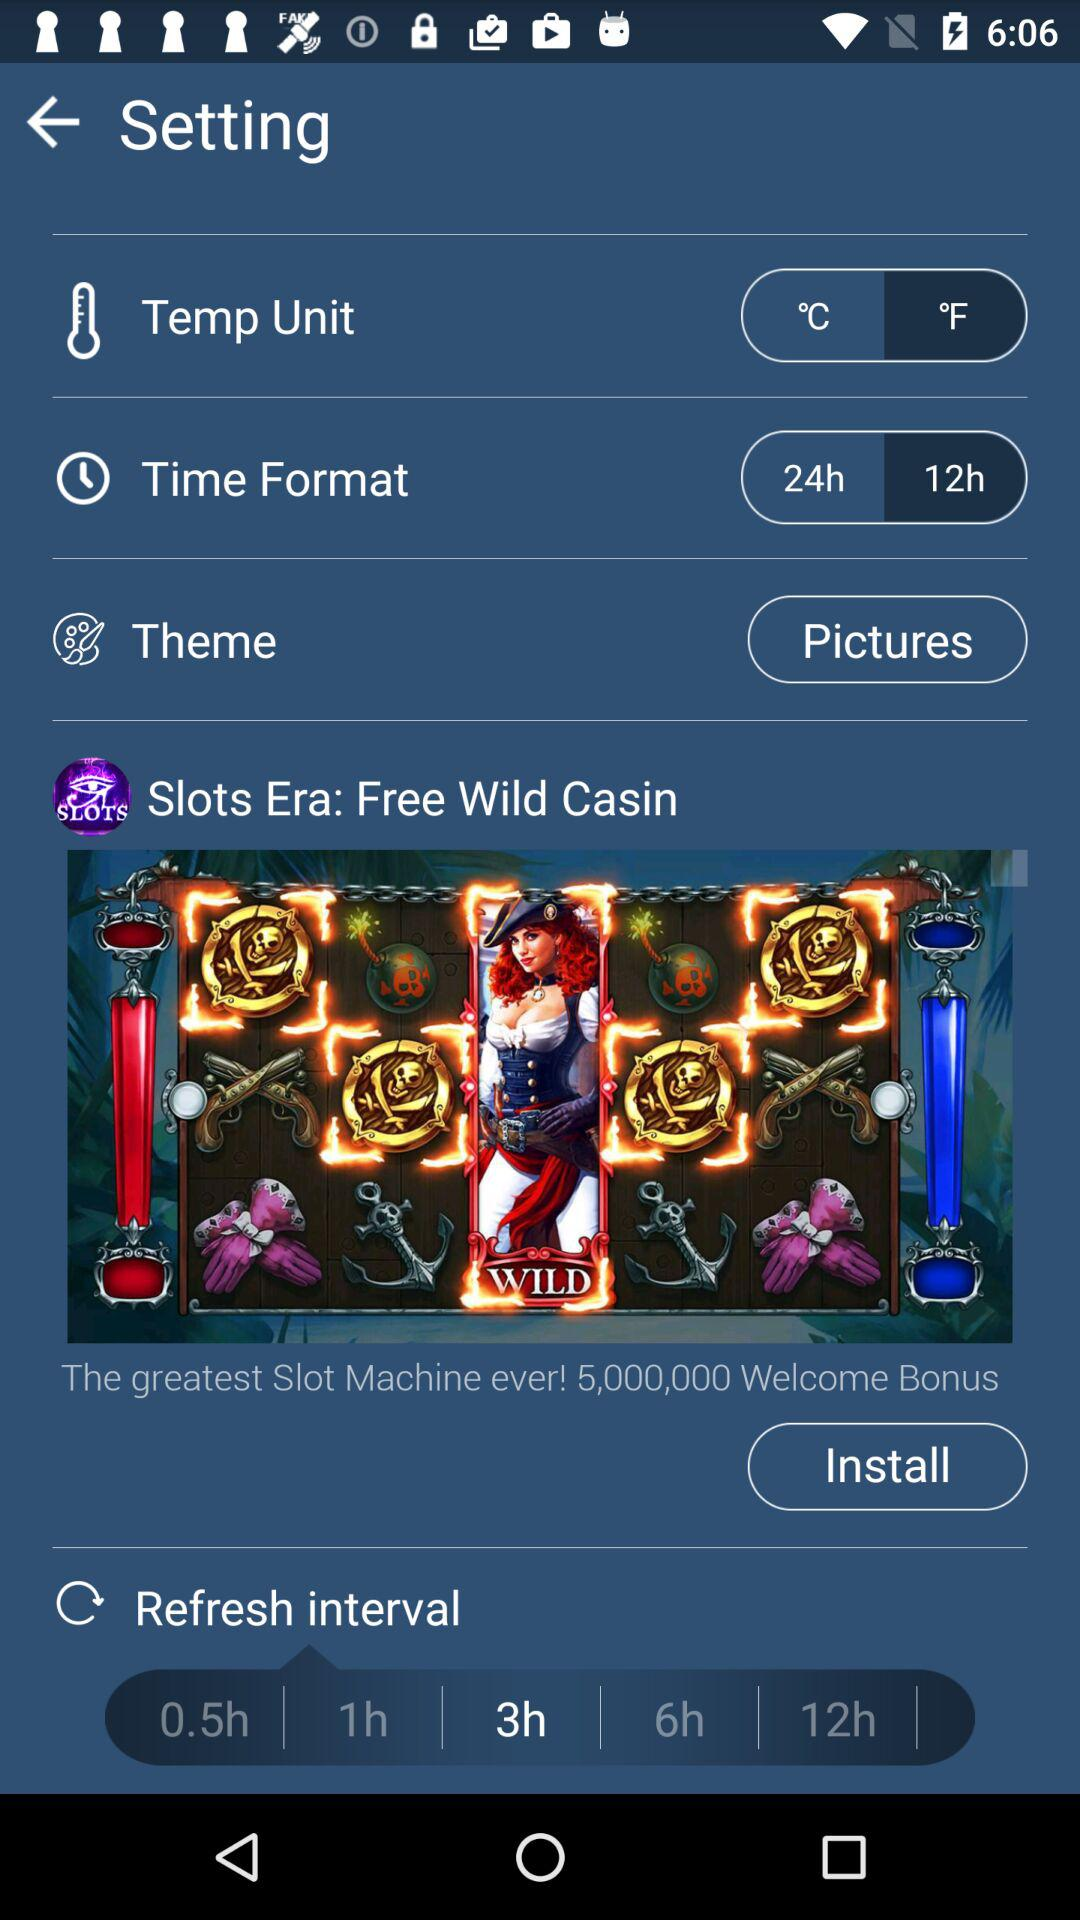What is the selected refresh interval? The selected refresh interval is 3 hours. 